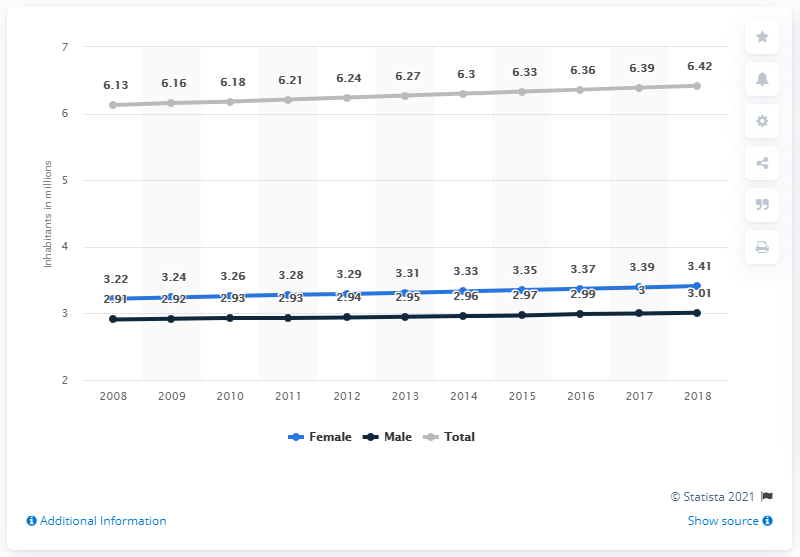How many men lived in El Salvador in 2018? In 2018, the male population of El Salvador was approximately 3.01 million, as depicted in the statistical data provided. 